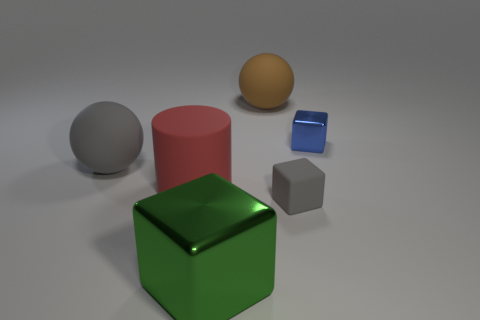The large gray rubber thing has what shape?
Your response must be concise. Sphere. What is the color of the matte thing that is both in front of the gray matte ball and behind the gray block?
Your answer should be very brief. Red. What material is the big brown object?
Ensure brevity in your answer.  Rubber. What is the shape of the tiny object that is to the right of the tiny gray rubber thing?
Provide a succinct answer. Cube. The matte cylinder that is the same size as the green metallic block is what color?
Provide a succinct answer. Red. Is the material of the large sphere that is in front of the large brown matte ball the same as the tiny blue cube?
Offer a terse response. No. There is a rubber thing that is both to the right of the red rubber object and in front of the gray sphere; how big is it?
Offer a terse response. Small. How big is the red cylinder that is behind the small gray cube?
Your response must be concise. Large. There is a gray rubber thing that is to the left of the shiny thing to the left of the sphere right of the green shiny thing; what is its shape?
Keep it short and to the point. Sphere. What number of other things are the same shape as the blue thing?
Give a very brief answer. 2. 